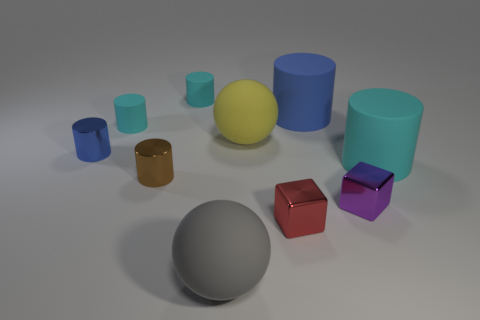There is a brown object that is the same size as the blue shiny cylinder; what material is it?
Ensure brevity in your answer.  Metal. Are there any tiny blue cylinders that have the same material as the small purple object?
Your answer should be compact. Yes. What shape is the cyan thing on the right side of the ball that is on the left side of the big matte ball on the right side of the gray sphere?
Offer a terse response. Cylinder. Does the brown cylinder have the same size as the shiny thing in front of the tiny purple cube?
Ensure brevity in your answer.  Yes. What shape is the tiny metallic object that is to the right of the tiny blue metallic cylinder and behind the tiny purple metal block?
Keep it short and to the point. Cylinder. How many large things are either red things or red balls?
Your response must be concise. 0. Are there an equal number of big objects in front of the red shiny block and tiny cyan cylinders behind the blue matte cylinder?
Your answer should be very brief. Yes. Are there the same number of cyan rubber cylinders that are behind the small blue metal cylinder and small shiny blocks?
Keep it short and to the point. Yes. Do the blue matte object and the yellow ball have the same size?
Ensure brevity in your answer.  Yes. There is a cylinder that is both in front of the blue metallic cylinder and left of the large gray thing; what material is it?
Ensure brevity in your answer.  Metal. 